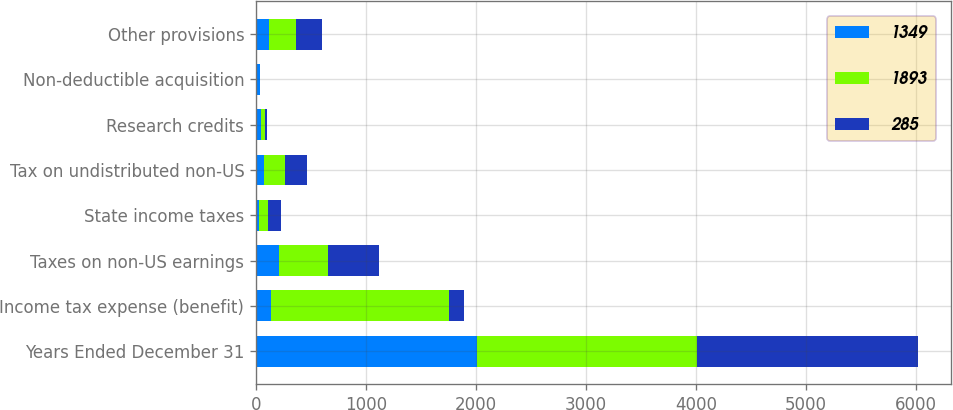Convert chart. <chart><loc_0><loc_0><loc_500><loc_500><stacked_bar_chart><ecel><fcel>Years Ended December 31<fcel>Income tax expense (benefit)<fcel>Taxes on non-US earnings<fcel>State income taxes<fcel>Tax on undistributed non-US<fcel>Research credits<fcel>Non-deductible acquisition<fcel>Other provisions<nl><fcel>1349<fcel>2007<fcel>137<fcel>206<fcel>28<fcel>72<fcel>46<fcel>34<fcel>119<nl><fcel>1893<fcel>2006<fcel>1613<fcel>449<fcel>77<fcel>194<fcel>34<fcel>4<fcel>247<nl><fcel>285<fcel>2005<fcel>137<fcel>460<fcel>121<fcel>202<fcel>23<fcel>2<fcel>233<nl></chart> 